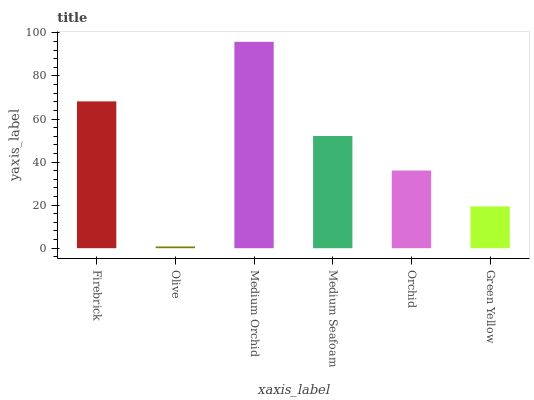Is Olive the minimum?
Answer yes or no. Yes. Is Medium Orchid the maximum?
Answer yes or no. Yes. Is Medium Orchid the minimum?
Answer yes or no. No. Is Olive the maximum?
Answer yes or no. No. Is Medium Orchid greater than Olive?
Answer yes or no. Yes. Is Olive less than Medium Orchid?
Answer yes or no. Yes. Is Olive greater than Medium Orchid?
Answer yes or no. No. Is Medium Orchid less than Olive?
Answer yes or no. No. Is Medium Seafoam the high median?
Answer yes or no. Yes. Is Orchid the low median?
Answer yes or no. Yes. Is Olive the high median?
Answer yes or no. No. Is Green Yellow the low median?
Answer yes or no. No. 